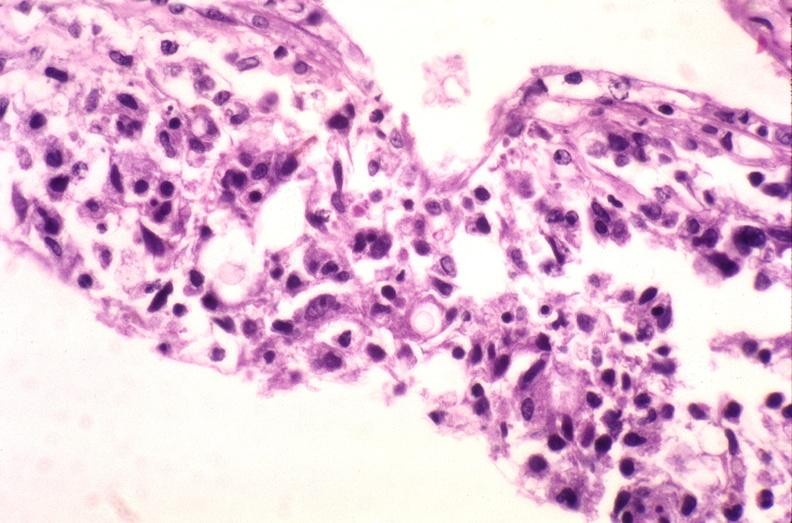does medial aspect show brain, cryptococcal meningitis?
Answer the question using a single word or phrase. No 